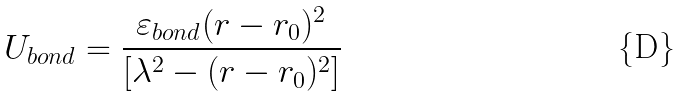Convert formula to latex. <formula><loc_0><loc_0><loc_500><loc_500>U _ { b o n d } = \frac { \varepsilon _ { b o n d } ( r - r _ { 0 } ) ^ { 2 } } { [ \lambda ^ { 2 } - ( r - r _ { 0 } ) ^ { 2 } ] }</formula> 